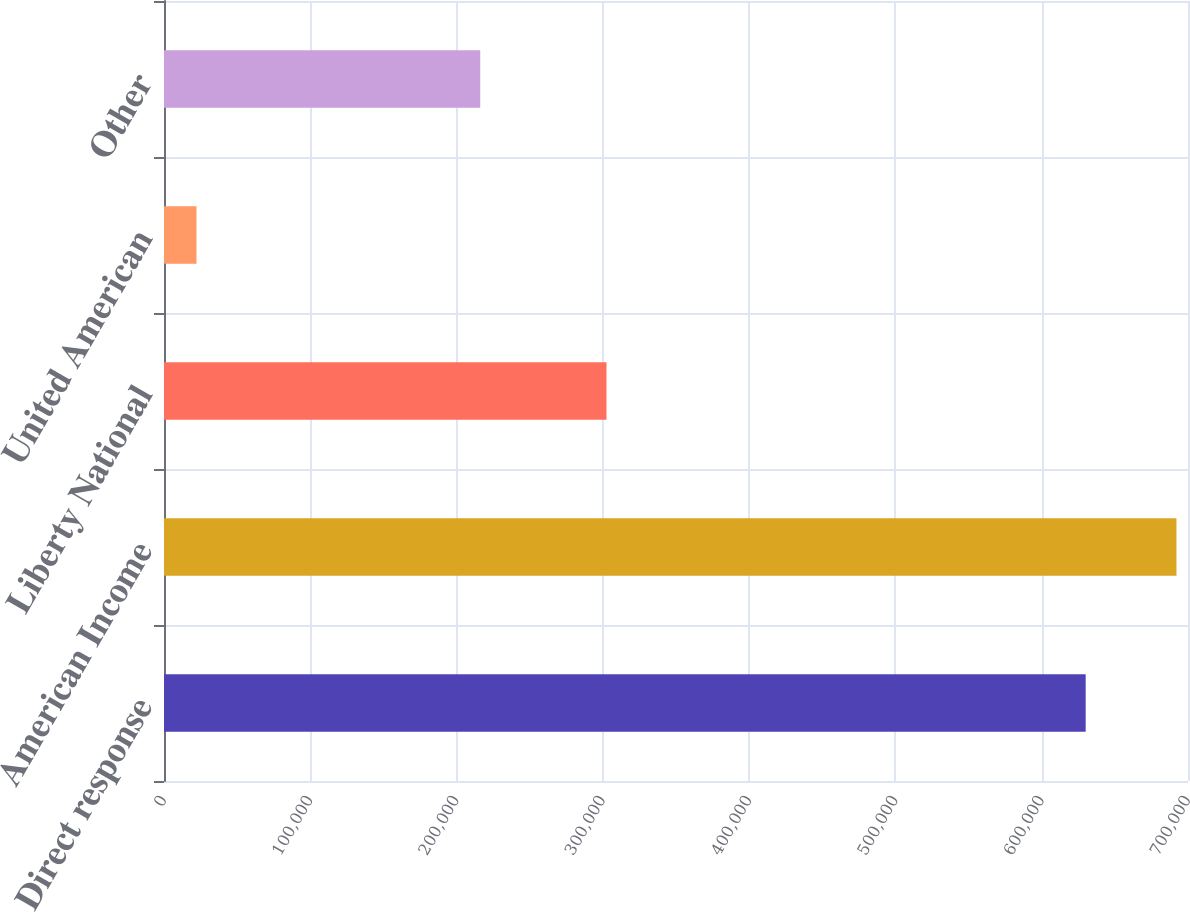Convert chart. <chart><loc_0><loc_0><loc_500><loc_500><bar_chart><fcel>Direct response<fcel>American Income<fcel>Liberty National<fcel>United American<fcel>Other<nl><fcel>630044<fcel>692104<fcel>302489<fcel>22203<fcel>216166<nl></chart> 